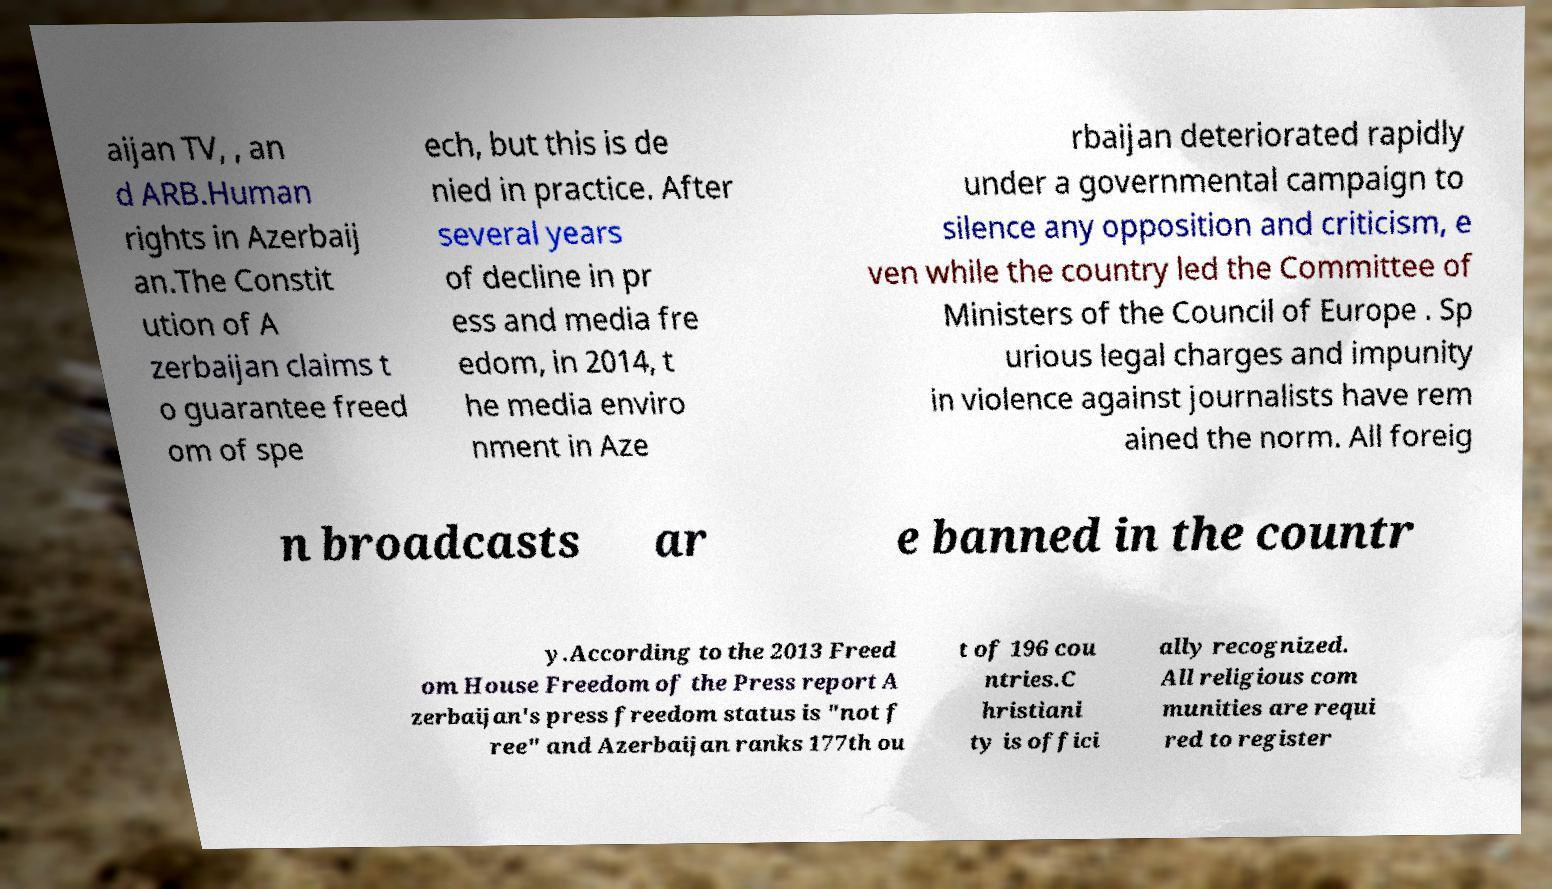There's text embedded in this image that I need extracted. Can you transcribe it verbatim? aijan TV, , an d ARB.Human rights in Azerbaij an.The Constit ution of A zerbaijan claims t o guarantee freed om of spe ech, but this is de nied in practice. After several years of decline in pr ess and media fre edom, in 2014, t he media enviro nment in Aze rbaijan deteriorated rapidly under a governmental campaign to silence any opposition and criticism, e ven while the country led the Committee of Ministers of the Council of Europe . Sp urious legal charges and impunity in violence against journalists have rem ained the norm. All foreig n broadcasts ar e banned in the countr y.According to the 2013 Freed om House Freedom of the Press report A zerbaijan's press freedom status is "not f ree" and Azerbaijan ranks 177th ou t of 196 cou ntries.C hristiani ty is offici ally recognized. All religious com munities are requi red to register 